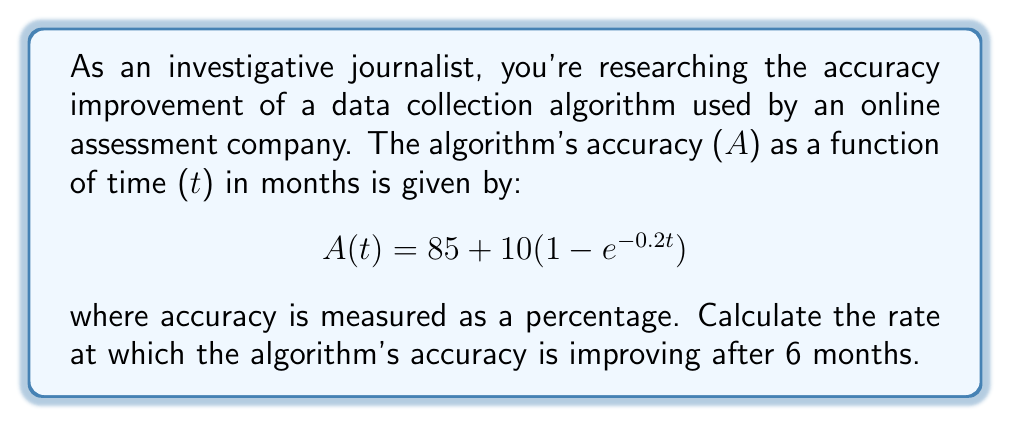Can you solve this math problem? To solve this problem, we need to find the derivative of the accuracy function and evaluate it at t = 6 months. This will give us the instantaneous rate of change in accuracy at that point.

1. First, let's find the derivative of A(t):
   $$\frac{d}{dt}A(t) = \frac{d}{dt}[85 + 10(1 - e^{-0.2t})]$$
   $$A'(t) = 0 + 10 \cdot \frac{d}{dt}(1 - e^{-0.2t})$$
   $$A'(t) = 10 \cdot (0 - (-0.2)e^{-0.2t})$$
   $$A'(t) = 2e^{-0.2t}$$

2. Now, we evaluate A'(t) at t = 6:
   $$A'(6) = 2e^{-0.2(6)}$$
   $$A'(6) = 2e^{-1.2}$$

3. Calculate the final value:
   $$A'(6) \approx 2 \cdot 0.301194 \approx 0.602388$$

This result represents the rate of change in accuracy per month at t = 6 months.
Answer: The rate at which the algorithm's accuracy is improving after 6 months is approximately 0.602388% per month. 